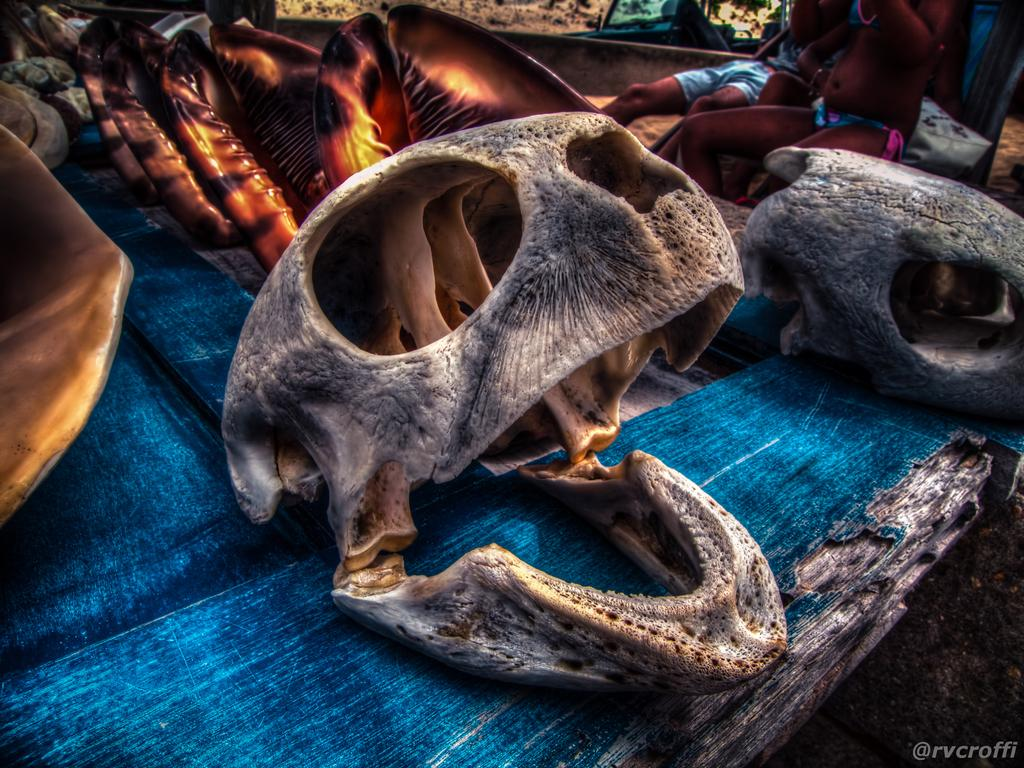What is the main subject of the image? The main subject of the image is a skull of an animal. Can you describe the people in the background of the image? There are people sitting in the background of the image. What is the opinion of the ghost in the image about the baseball game? There is no ghost or baseball game present in the image, so it is not possible to determine the ghost's opinion about a baseball game. 